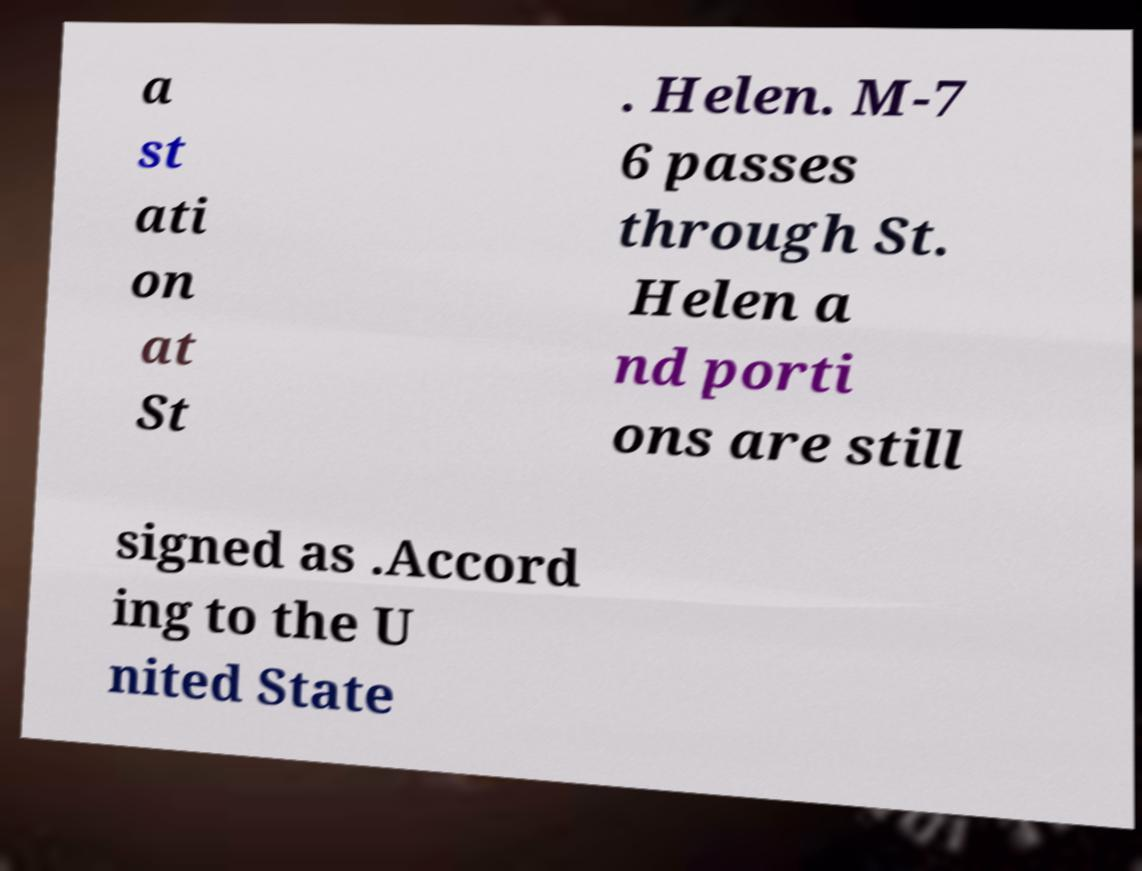Please identify and transcribe the text found in this image. a st ati on at St . Helen. M-7 6 passes through St. Helen a nd porti ons are still signed as .Accord ing to the U nited State 